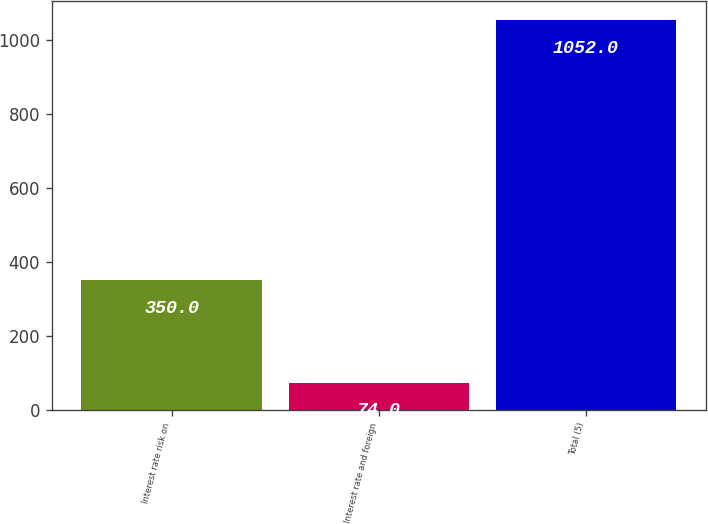<chart> <loc_0><loc_0><loc_500><loc_500><bar_chart><fcel>Interest rate risk on<fcel>Interest rate and foreign<fcel>Total (5)<nl><fcel>350<fcel>74<fcel>1052<nl></chart> 